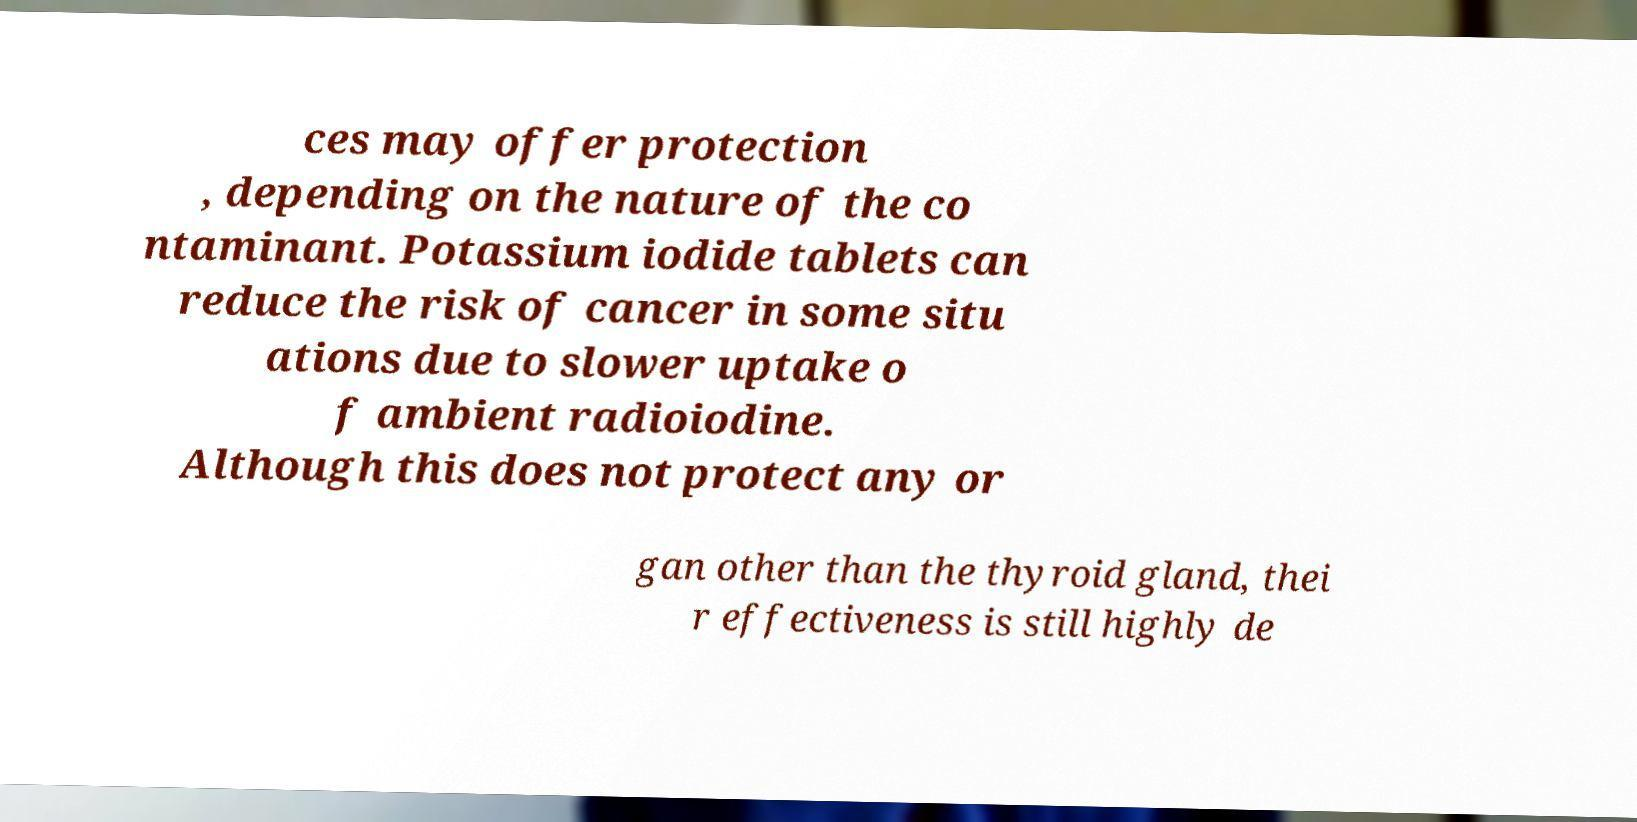I need the written content from this picture converted into text. Can you do that? ces may offer protection , depending on the nature of the co ntaminant. Potassium iodide tablets can reduce the risk of cancer in some situ ations due to slower uptake o f ambient radioiodine. Although this does not protect any or gan other than the thyroid gland, thei r effectiveness is still highly de 